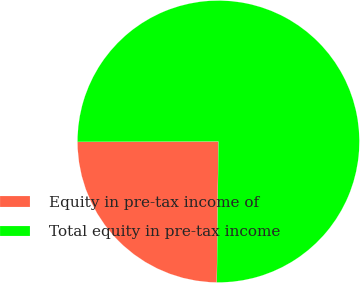Convert chart to OTSL. <chart><loc_0><loc_0><loc_500><loc_500><pie_chart><fcel>Equity in pre-tax income of<fcel>Total equity in pre-tax income<nl><fcel>24.78%<fcel>75.22%<nl></chart> 